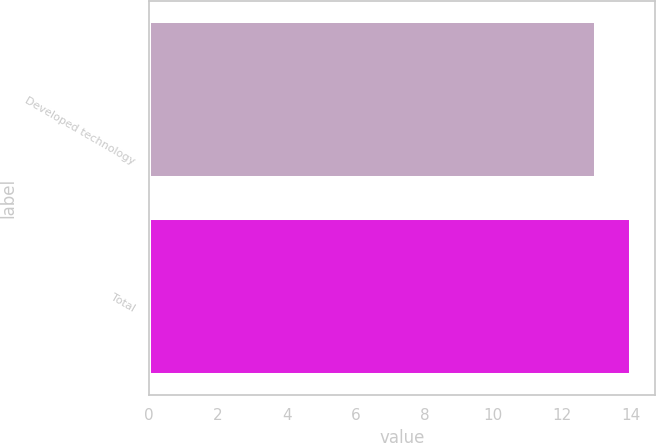<chart> <loc_0><loc_0><loc_500><loc_500><bar_chart><fcel>Developed technology<fcel>Total<nl><fcel>13<fcel>14<nl></chart> 